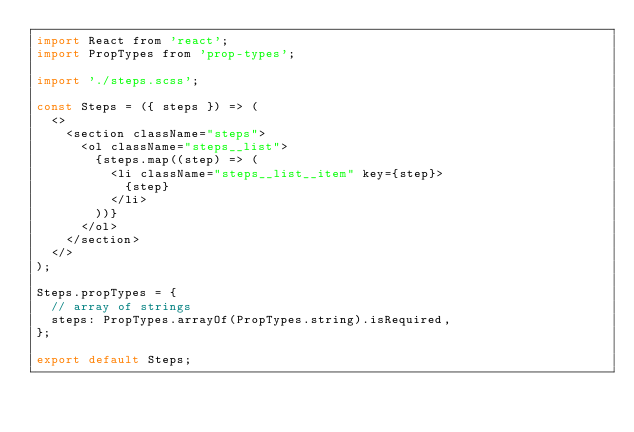<code> <loc_0><loc_0><loc_500><loc_500><_JavaScript_>import React from 'react';
import PropTypes from 'prop-types';

import './steps.scss';

const Steps = ({ steps }) => (
  <>
    <section className="steps">
      <ol className="steps__list">
        {steps.map((step) => (
          <li className="steps__list__item" key={step}>
            {step}
          </li>
        ))}
      </ol>
    </section>
  </>
);

Steps.propTypes = {
  // array of strings
  steps: PropTypes.arrayOf(PropTypes.string).isRequired,
};

export default Steps;
</code> 